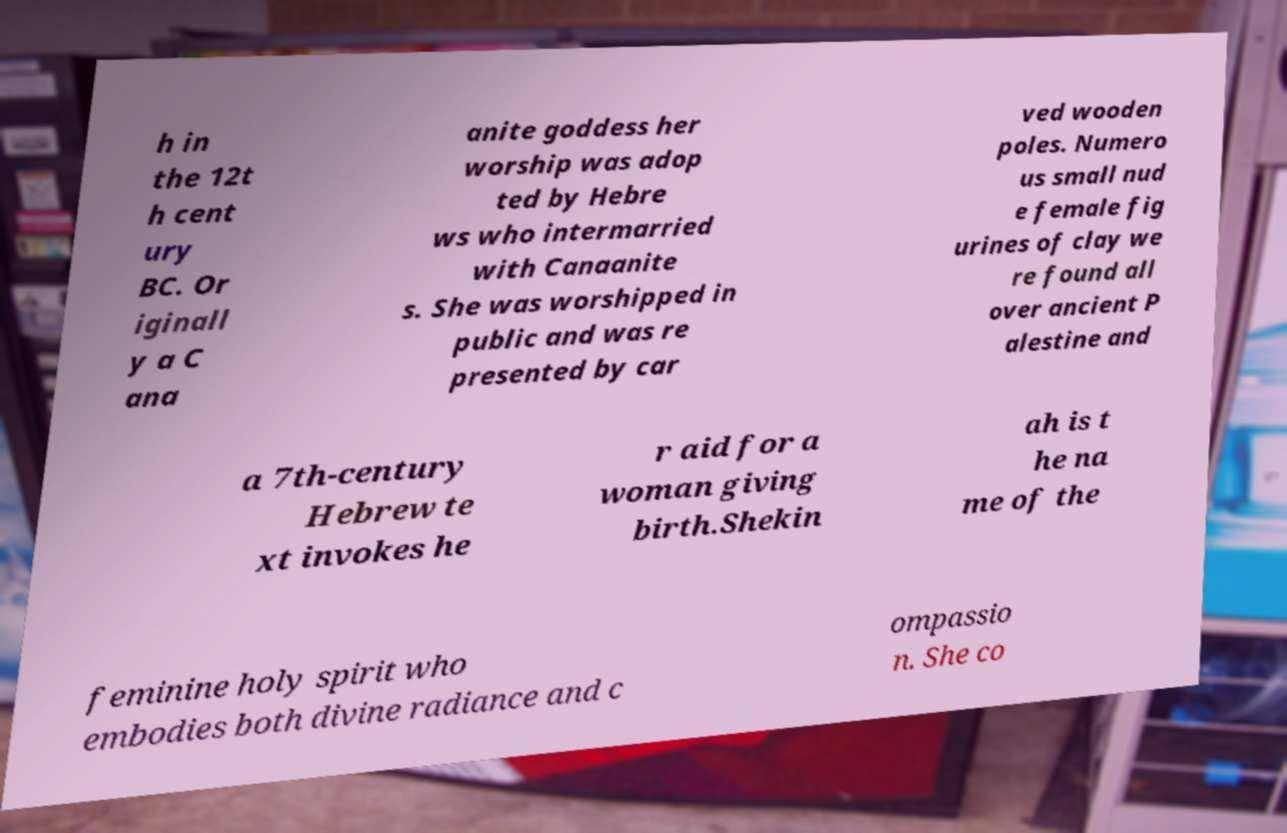Can you accurately transcribe the text from the provided image for me? h in the 12t h cent ury BC. Or iginall y a C ana anite goddess her worship was adop ted by Hebre ws who intermarried with Canaanite s. She was worshipped in public and was re presented by car ved wooden poles. Numero us small nud e female fig urines of clay we re found all over ancient P alestine and a 7th-century Hebrew te xt invokes he r aid for a woman giving birth.Shekin ah is t he na me of the feminine holy spirit who embodies both divine radiance and c ompassio n. She co 